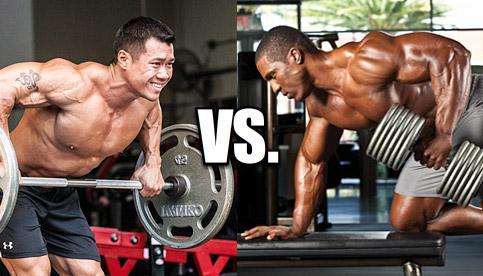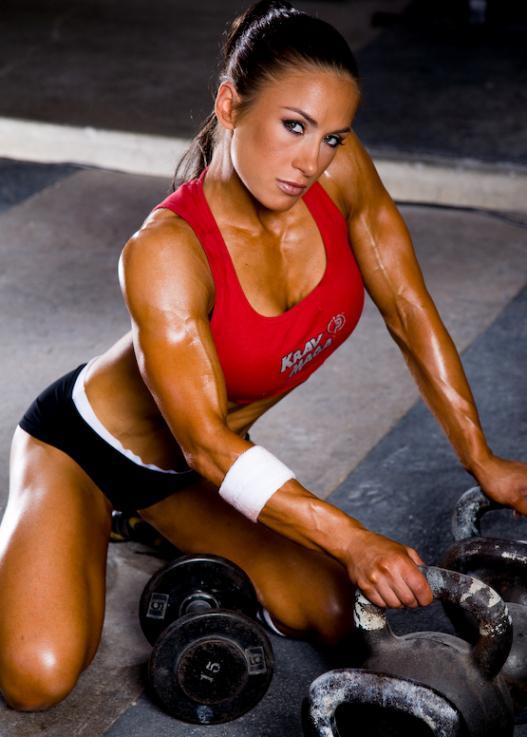The first image is the image on the left, the second image is the image on the right. For the images shown, is this caption "At least one image features a woman." true? Answer yes or no. Yes. 